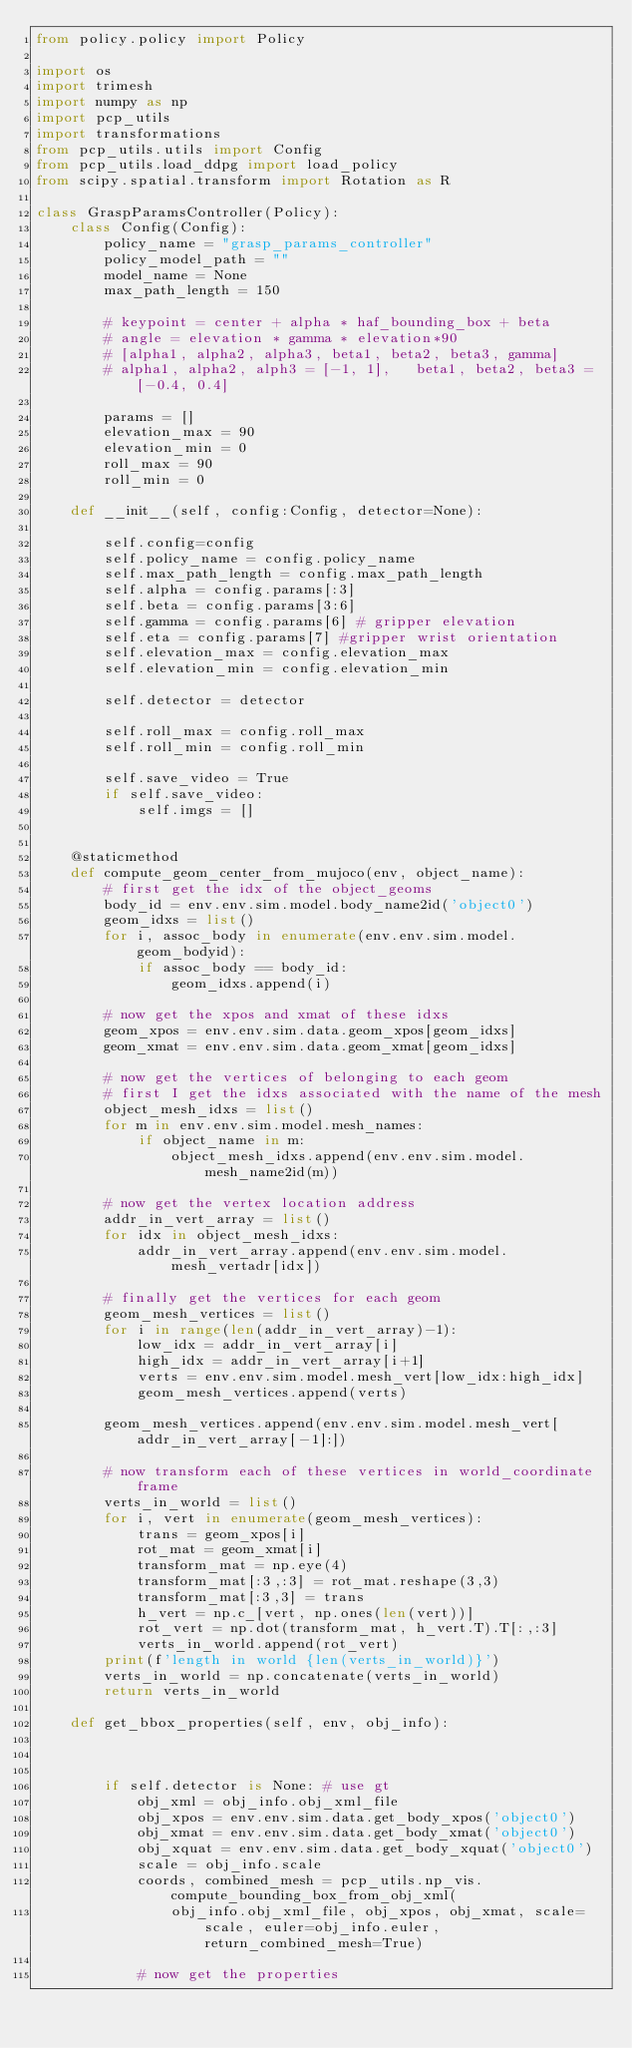<code> <loc_0><loc_0><loc_500><loc_500><_Python_>from policy.policy import Policy

import os
import trimesh
import numpy as np
import pcp_utils
import transformations
from pcp_utils.utils import Config
from pcp_utils.load_ddpg import load_policy
from scipy.spatial.transform import Rotation as R

class GraspParamsController(Policy):
    class Config(Config):
        policy_name = "grasp_params_controller"
        policy_model_path = ""
        model_name = None
        max_path_length = 150

        # keypoint = center + alpha * haf_bounding_box + beta
        # angle = elevation * gamma * elevation*90
        # [alpha1, alpha2, alpha3, beta1, beta2, beta3, gamma]
        # alpha1, alpha2, alph3 = [-1, 1],   beta1, beta2, beta3 = [-0.4, 0.4]

        params = []
        elevation_max = 90
        elevation_min = 0
        roll_max = 90
        roll_min = 0

    def __init__(self, config:Config, detector=None):

        self.config=config
        self.policy_name = config.policy_name
        self.max_path_length = config.max_path_length
        self.alpha = config.params[:3]
        self.beta = config.params[3:6]
        self.gamma = config.params[6] # gripper elevation
        self.eta = config.params[7] #gripper wrist orientation
        self.elevation_max = config.elevation_max
        self.elevation_min = config.elevation_min

        self.detector = detector

        self.roll_max = config.roll_max
        self.roll_min = config.roll_min

        self.save_video = True
        if self.save_video:
            self.imgs = []


    @staticmethod
    def compute_geom_center_from_mujoco(env, object_name):
        # first get the idx of the object_geoms
        body_id = env.env.sim.model.body_name2id('object0')
        geom_idxs = list()
        for i, assoc_body in enumerate(env.env.sim.model.geom_bodyid):
            if assoc_body == body_id:
                geom_idxs.append(i)

        # now get the xpos and xmat of these idxs
        geom_xpos = env.env.sim.data.geom_xpos[geom_idxs]
        geom_xmat = env.env.sim.data.geom_xmat[geom_idxs]

        # now get the vertices of belonging to each geom
        # first I get the idxs associated with the name of the mesh
        object_mesh_idxs = list()
        for m in env.env.sim.model.mesh_names:
            if object_name in m:
                object_mesh_idxs.append(env.env.sim.model.mesh_name2id(m))
        
        # now get the vertex location address
        addr_in_vert_array = list()
        for idx in object_mesh_idxs:
            addr_in_vert_array.append(env.env.sim.model.mesh_vertadr[idx])

        # finally get the vertices for each geom
        geom_mesh_vertices = list()
        for i in range(len(addr_in_vert_array)-1):
            low_idx = addr_in_vert_array[i]
            high_idx = addr_in_vert_array[i+1]
            verts = env.env.sim.model.mesh_vert[low_idx:high_idx]
            geom_mesh_vertices.append(verts)
        
        geom_mesh_vertices.append(env.env.sim.model.mesh_vert[addr_in_vert_array[-1]:])

        # now transform each of these vertices in world_coordinate frame
        verts_in_world = list()
        for i, vert in enumerate(geom_mesh_vertices):
            trans = geom_xpos[i]
            rot_mat = geom_xmat[i]
            transform_mat = np.eye(4)
            transform_mat[:3,:3] = rot_mat.reshape(3,3)
            transform_mat[:3,3] = trans
            h_vert = np.c_[vert, np.ones(len(vert))]
            rot_vert = np.dot(transform_mat, h_vert.T).T[:,:3]
            verts_in_world.append(rot_vert)
        print(f'length in world {len(verts_in_world)}')
        verts_in_world = np.concatenate(verts_in_world)
        return verts_in_world

    def get_bbox_properties(self, env, obj_info):



        if self.detector is None: # use gt
            obj_xml = obj_info.obj_xml_file
            obj_xpos = env.env.sim.data.get_body_xpos('object0')
            obj_xmat = env.env.sim.data.get_body_xmat('object0')
            obj_xquat = env.env.sim.data.get_body_xquat('object0')
            scale = obj_info.scale
            coords, combined_mesh = pcp_utils.np_vis.compute_bounding_box_from_obj_xml(
                obj_info.obj_xml_file, obj_xpos, obj_xmat, scale=scale, euler=obj_info.euler, return_combined_mesh=True)
    
            # now get the properties</code> 